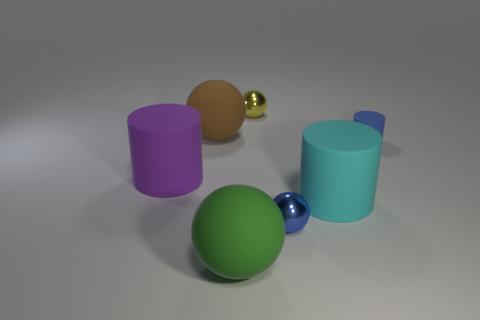Subtract all red spheres. Subtract all brown blocks. How many spheres are left? 4 Add 2 big blue balls. How many objects exist? 9 Subtract all cylinders. How many objects are left? 4 Subtract 1 green spheres. How many objects are left? 6 Subtract all metal balls. Subtract all green rubber balls. How many objects are left? 4 Add 4 big purple matte things. How many big purple matte things are left? 5 Add 4 matte cylinders. How many matte cylinders exist? 7 